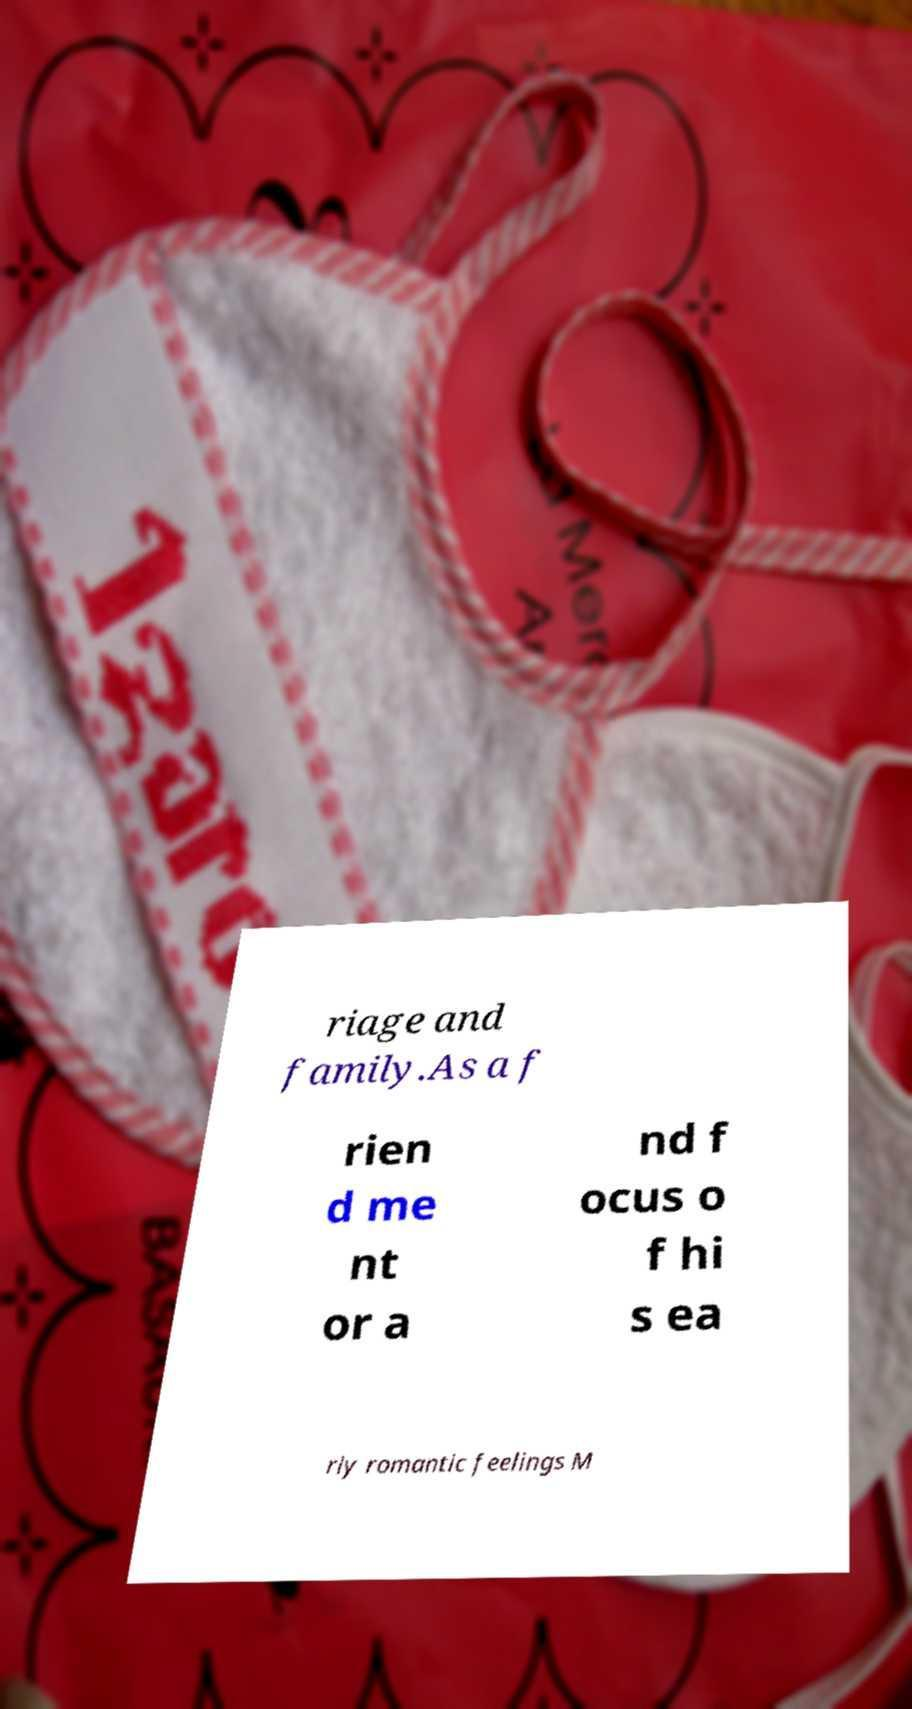There's text embedded in this image that I need extracted. Can you transcribe it verbatim? riage and family.As a f rien d me nt or a nd f ocus o f hi s ea rly romantic feelings M 